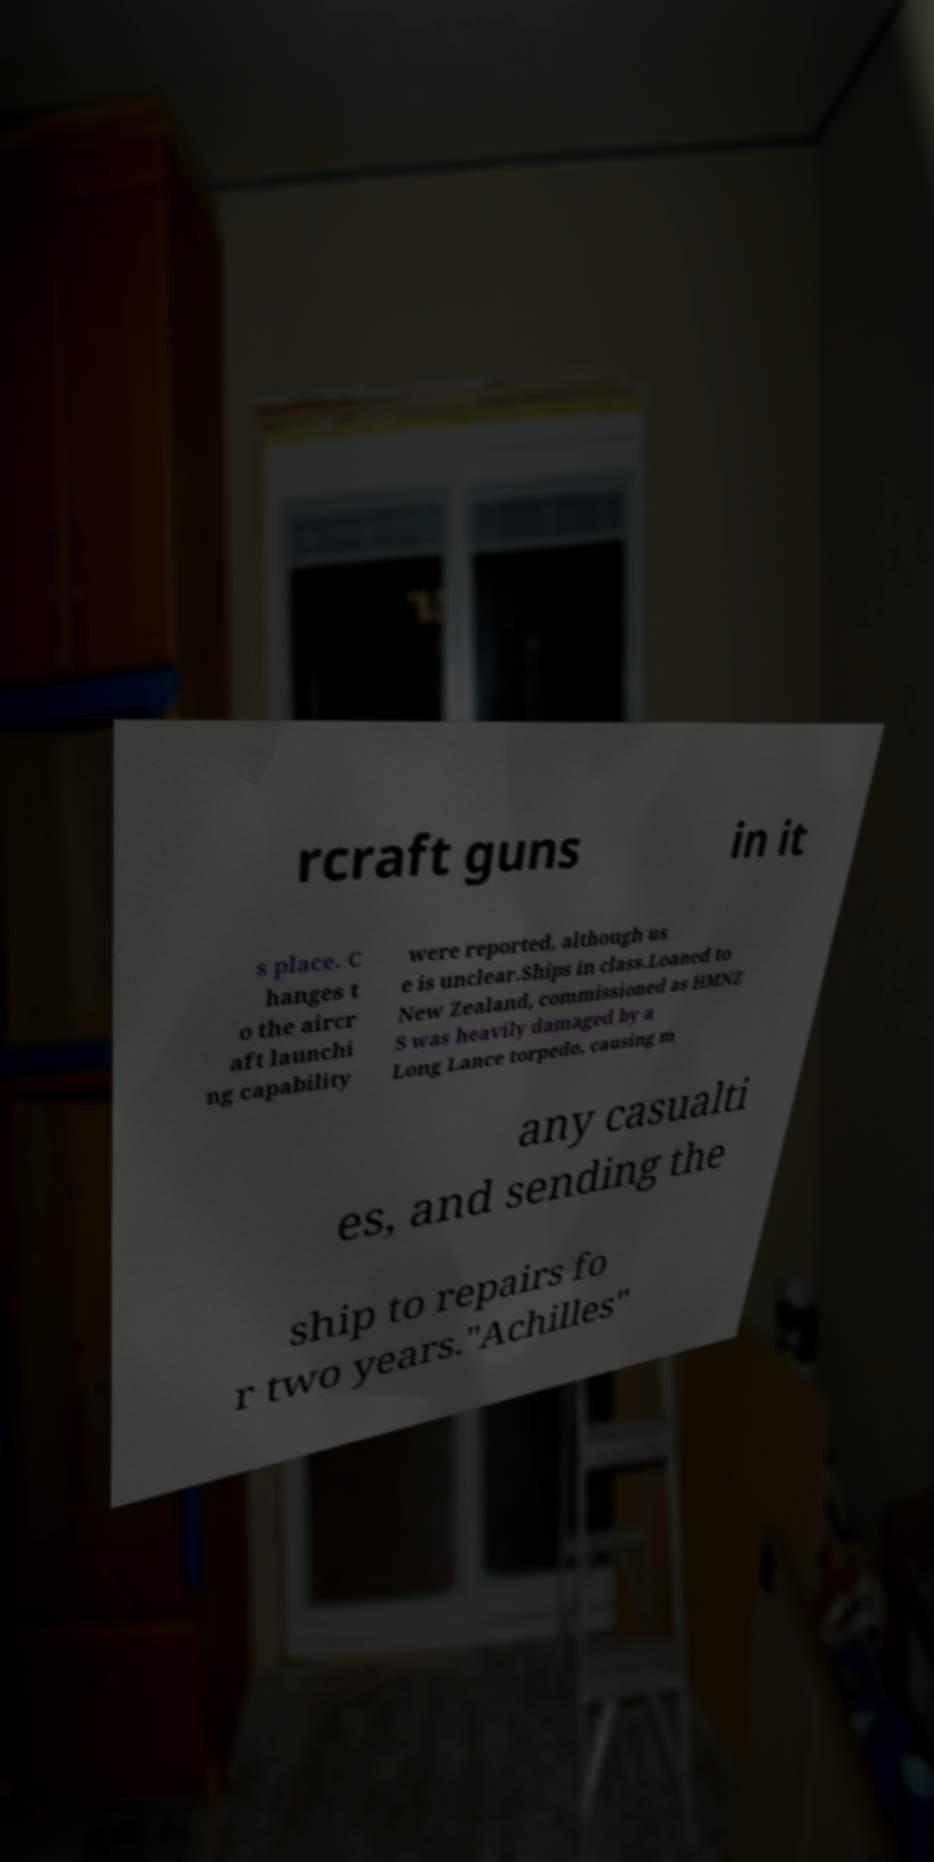Please identify and transcribe the text found in this image. rcraft guns in it s place. C hanges t o the aircr aft launchi ng capability were reported, although us e is unclear.Ships in class.Loaned to New Zealand, commissioned as HMNZ S was heavily damaged by a Long Lance torpedo, causing m any casualti es, and sending the ship to repairs fo r two years."Achilles" 